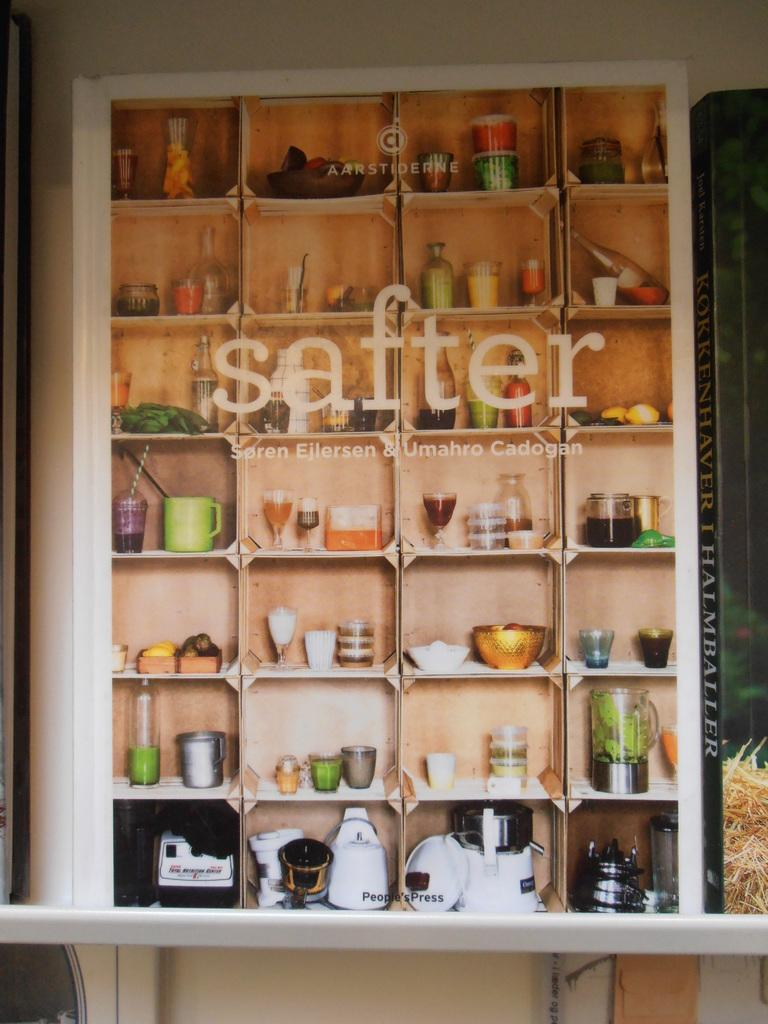<image>
Relay a brief, clear account of the picture shown. A "safter" display shows a bunch of kitchen gadgets, glasses, bowls and things. 